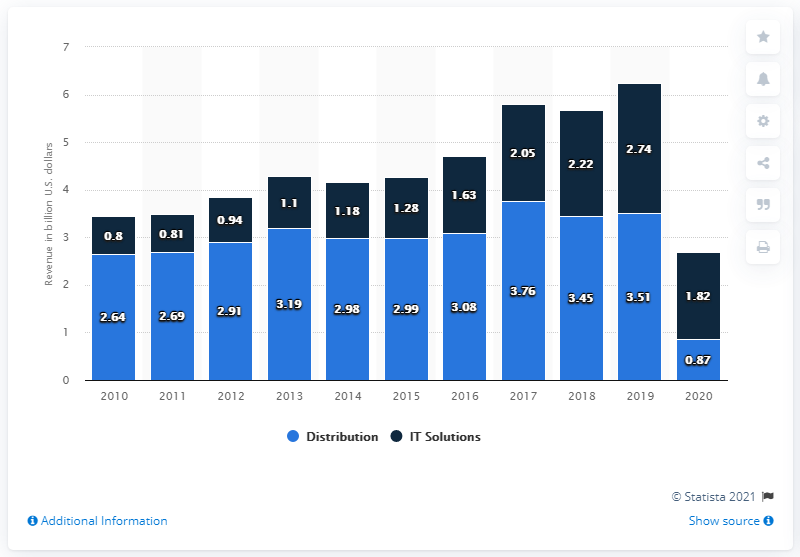Highlight a few significant elements in this photo. The total revenue of Amadeus in 2020 was 2.64 billion. The distribution systems business segment of Amadeus generated approximately 0.87 million U.S. dollars in 2020. 